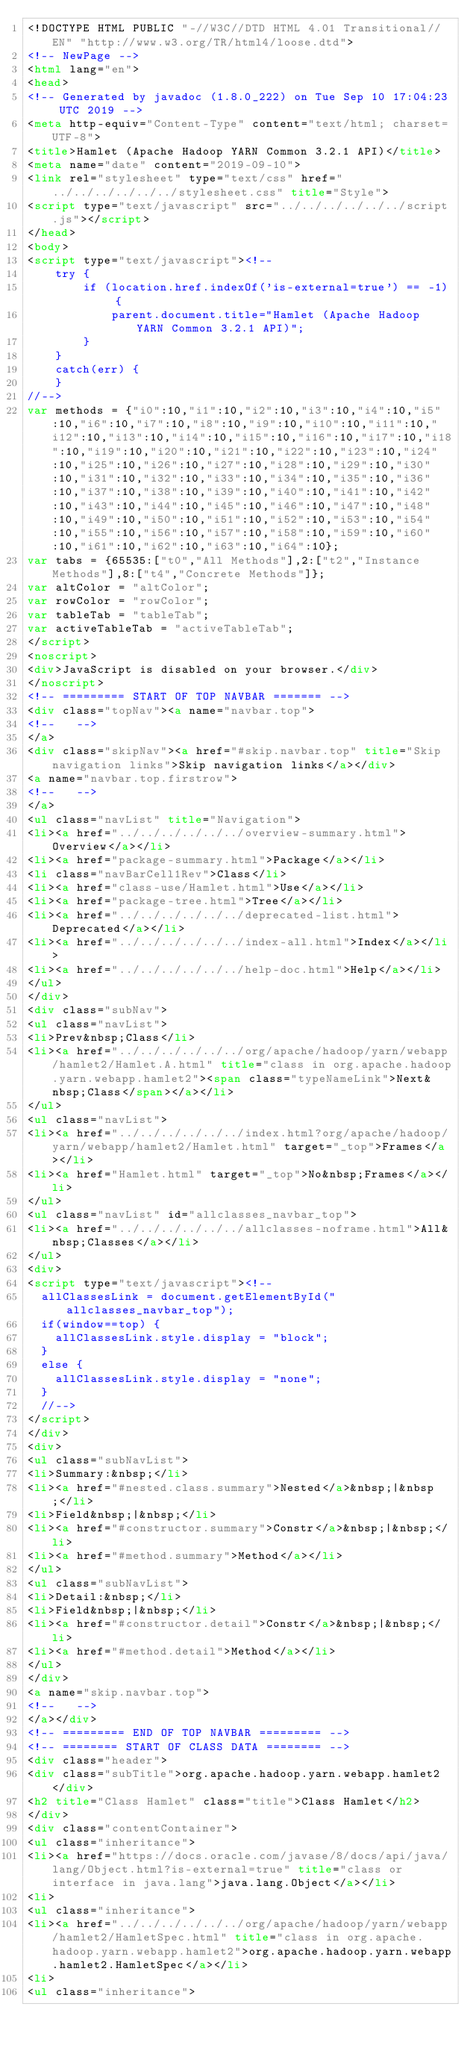Convert code to text. <code><loc_0><loc_0><loc_500><loc_500><_HTML_><!DOCTYPE HTML PUBLIC "-//W3C//DTD HTML 4.01 Transitional//EN" "http://www.w3.org/TR/html4/loose.dtd">
<!-- NewPage -->
<html lang="en">
<head>
<!-- Generated by javadoc (1.8.0_222) on Tue Sep 10 17:04:23 UTC 2019 -->
<meta http-equiv="Content-Type" content="text/html; charset=UTF-8">
<title>Hamlet (Apache Hadoop YARN Common 3.2.1 API)</title>
<meta name="date" content="2019-09-10">
<link rel="stylesheet" type="text/css" href="../../../../../../stylesheet.css" title="Style">
<script type="text/javascript" src="../../../../../../script.js"></script>
</head>
<body>
<script type="text/javascript"><!--
    try {
        if (location.href.indexOf('is-external=true') == -1) {
            parent.document.title="Hamlet (Apache Hadoop YARN Common 3.2.1 API)";
        }
    }
    catch(err) {
    }
//-->
var methods = {"i0":10,"i1":10,"i2":10,"i3":10,"i4":10,"i5":10,"i6":10,"i7":10,"i8":10,"i9":10,"i10":10,"i11":10,"i12":10,"i13":10,"i14":10,"i15":10,"i16":10,"i17":10,"i18":10,"i19":10,"i20":10,"i21":10,"i22":10,"i23":10,"i24":10,"i25":10,"i26":10,"i27":10,"i28":10,"i29":10,"i30":10,"i31":10,"i32":10,"i33":10,"i34":10,"i35":10,"i36":10,"i37":10,"i38":10,"i39":10,"i40":10,"i41":10,"i42":10,"i43":10,"i44":10,"i45":10,"i46":10,"i47":10,"i48":10,"i49":10,"i50":10,"i51":10,"i52":10,"i53":10,"i54":10,"i55":10,"i56":10,"i57":10,"i58":10,"i59":10,"i60":10,"i61":10,"i62":10,"i63":10,"i64":10};
var tabs = {65535:["t0","All Methods"],2:["t2","Instance Methods"],8:["t4","Concrete Methods"]};
var altColor = "altColor";
var rowColor = "rowColor";
var tableTab = "tableTab";
var activeTableTab = "activeTableTab";
</script>
<noscript>
<div>JavaScript is disabled on your browser.</div>
</noscript>
<!-- ========= START OF TOP NAVBAR ======= -->
<div class="topNav"><a name="navbar.top">
<!--   -->
</a>
<div class="skipNav"><a href="#skip.navbar.top" title="Skip navigation links">Skip navigation links</a></div>
<a name="navbar.top.firstrow">
<!--   -->
</a>
<ul class="navList" title="Navigation">
<li><a href="../../../../../../overview-summary.html">Overview</a></li>
<li><a href="package-summary.html">Package</a></li>
<li class="navBarCell1Rev">Class</li>
<li><a href="class-use/Hamlet.html">Use</a></li>
<li><a href="package-tree.html">Tree</a></li>
<li><a href="../../../../../../deprecated-list.html">Deprecated</a></li>
<li><a href="../../../../../../index-all.html">Index</a></li>
<li><a href="../../../../../../help-doc.html">Help</a></li>
</ul>
</div>
<div class="subNav">
<ul class="navList">
<li>Prev&nbsp;Class</li>
<li><a href="../../../../../../org/apache/hadoop/yarn/webapp/hamlet2/Hamlet.A.html" title="class in org.apache.hadoop.yarn.webapp.hamlet2"><span class="typeNameLink">Next&nbsp;Class</span></a></li>
</ul>
<ul class="navList">
<li><a href="../../../../../../index.html?org/apache/hadoop/yarn/webapp/hamlet2/Hamlet.html" target="_top">Frames</a></li>
<li><a href="Hamlet.html" target="_top">No&nbsp;Frames</a></li>
</ul>
<ul class="navList" id="allclasses_navbar_top">
<li><a href="../../../../../../allclasses-noframe.html">All&nbsp;Classes</a></li>
</ul>
<div>
<script type="text/javascript"><!--
  allClassesLink = document.getElementById("allclasses_navbar_top");
  if(window==top) {
    allClassesLink.style.display = "block";
  }
  else {
    allClassesLink.style.display = "none";
  }
  //-->
</script>
</div>
<div>
<ul class="subNavList">
<li>Summary:&nbsp;</li>
<li><a href="#nested.class.summary">Nested</a>&nbsp;|&nbsp;</li>
<li>Field&nbsp;|&nbsp;</li>
<li><a href="#constructor.summary">Constr</a>&nbsp;|&nbsp;</li>
<li><a href="#method.summary">Method</a></li>
</ul>
<ul class="subNavList">
<li>Detail:&nbsp;</li>
<li>Field&nbsp;|&nbsp;</li>
<li><a href="#constructor.detail">Constr</a>&nbsp;|&nbsp;</li>
<li><a href="#method.detail">Method</a></li>
</ul>
</div>
<a name="skip.navbar.top">
<!--   -->
</a></div>
<!-- ========= END OF TOP NAVBAR ========= -->
<!-- ======== START OF CLASS DATA ======== -->
<div class="header">
<div class="subTitle">org.apache.hadoop.yarn.webapp.hamlet2</div>
<h2 title="Class Hamlet" class="title">Class Hamlet</h2>
</div>
<div class="contentContainer">
<ul class="inheritance">
<li><a href="https://docs.oracle.com/javase/8/docs/api/java/lang/Object.html?is-external=true" title="class or interface in java.lang">java.lang.Object</a></li>
<li>
<ul class="inheritance">
<li><a href="../../../../../../org/apache/hadoop/yarn/webapp/hamlet2/HamletSpec.html" title="class in org.apache.hadoop.yarn.webapp.hamlet2">org.apache.hadoop.yarn.webapp.hamlet2.HamletSpec</a></li>
<li>
<ul class="inheritance"></code> 